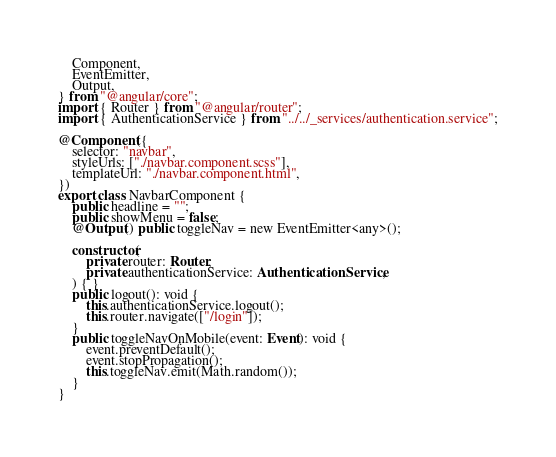Convert code to text. <code><loc_0><loc_0><loc_500><loc_500><_TypeScript_>    Component,
    EventEmitter,
    Output,
} from "@angular/core";
import { Router } from "@angular/router";
import { AuthenticationService } from "../../_services/authentication.service";

@Component({
    selector: "navbar",
    styleUrls: ["./navbar.component.scss"],
    templateUrl: "./navbar.component.html",
})
export class NavbarComponent {
    public headline = "";
    public showMenu = false;
    @Output() public toggleNav = new EventEmitter<any>();

    constructor(
        private router: Router,
        private authenticationService: AuthenticationService,
    ) { }
    public logout(): void {
        this.authenticationService.logout();
        this.router.navigate(["/login"]);
    }
    public toggleNavOnMobile(event: Event): void {
        event.preventDefault();
        event.stopPropagation();
        this.toggleNav.emit(Math.random());
    }
}
</code> 